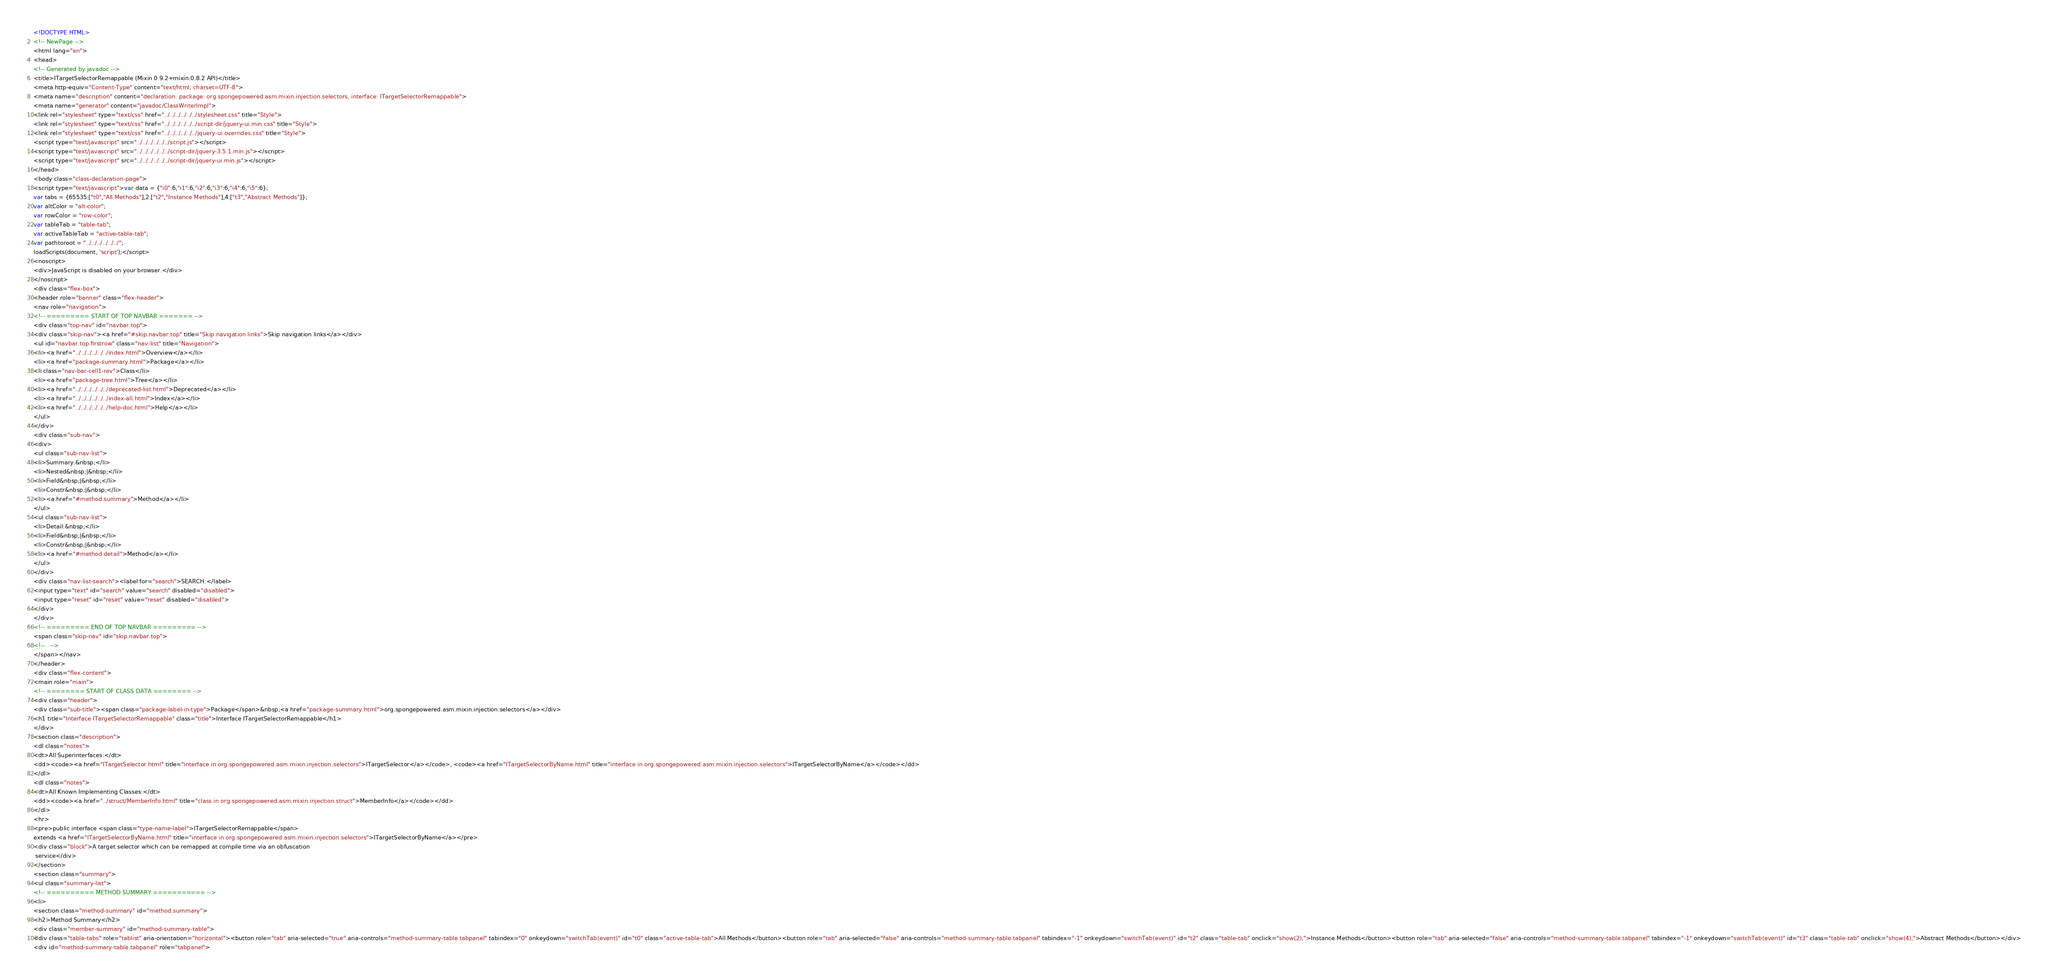Convert code to text. <code><loc_0><loc_0><loc_500><loc_500><_HTML_><!DOCTYPE HTML>
<!-- NewPage -->
<html lang="en">
<head>
<!-- Generated by javadoc -->
<title>ITargetSelectorRemappable (Mixin 0.9.2+mixin.0.8.2 API)</title>
<meta http-equiv="Content-Type" content="text/html; charset=UTF-8">
<meta name="description" content="declaration: package: org.spongepowered.asm.mixin.injection.selectors, interface: ITargetSelectorRemappable">
<meta name="generator" content="javadoc/ClassWriterImpl">
<link rel="stylesheet" type="text/css" href="../../../../../../stylesheet.css" title="Style">
<link rel="stylesheet" type="text/css" href="../../../../../../script-dir/jquery-ui.min.css" title="Style">
<link rel="stylesheet" type="text/css" href="../../../../../../jquery-ui.overrides.css" title="Style">
<script type="text/javascript" src="../../../../../../script.js"></script>
<script type="text/javascript" src="../../../../../../script-dir/jquery-3.5.1.min.js"></script>
<script type="text/javascript" src="../../../../../../script-dir/jquery-ui.min.js"></script>
</head>
<body class="class-declaration-page">
<script type="text/javascript">var data = {"i0":6,"i1":6,"i2":6,"i3":6,"i4":6,"i5":6};
var tabs = {65535:["t0","All Methods"],2:["t2","Instance Methods"],4:["t3","Abstract Methods"]};
var altColor = "alt-color";
var rowColor = "row-color";
var tableTab = "table-tab";
var activeTableTab = "active-table-tab";
var pathtoroot = "../../../../../../";
loadScripts(document, 'script');</script>
<noscript>
<div>JavaScript is disabled on your browser.</div>
</noscript>
<div class="flex-box">
<header role="banner" class="flex-header">
<nav role="navigation">
<!-- ========= START OF TOP NAVBAR ======= -->
<div class="top-nav" id="navbar.top">
<div class="skip-nav"><a href="#skip.navbar.top" title="Skip navigation links">Skip navigation links</a></div>
<ul id="navbar.top.firstrow" class="nav-list" title="Navigation">
<li><a href="../../../../../../index.html">Overview</a></li>
<li><a href="package-summary.html">Package</a></li>
<li class="nav-bar-cell1-rev">Class</li>
<li><a href="package-tree.html">Tree</a></li>
<li><a href="../../../../../../deprecated-list.html">Deprecated</a></li>
<li><a href="../../../../../../index-all.html">Index</a></li>
<li><a href="../../../../../../help-doc.html">Help</a></li>
</ul>
</div>
<div class="sub-nav">
<div>
<ul class="sub-nav-list">
<li>Summary:&nbsp;</li>
<li>Nested&nbsp;|&nbsp;</li>
<li>Field&nbsp;|&nbsp;</li>
<li>Constr&nbsp;|&nbsp;</li>
<li><a href="#method.summary">Method</a></li>
</ul>
<ul class="sub-nav-list">
<li>Detail:&nbsp;</li>
<li>Field&nbsp;|&nbsp;</li>
<li>Constr&nbsp;|&nbsp;</li>
<li><a href="#method.detail">Method</a></li>
</ul>
</div>
<div class="nav-list-search"><label for="search">SEARCH:</label>
<input type="text" id="search" value="search" disabled="disabled">
<input type="reset" id="reset" value="reset" disabled="disabled">
</div>
</div>
<!-- ========= END OF TOP NAVBAR ========= -->
<span class="skip-nav" id="skip.navbar.top">
<!--   -->
</span></nav>
</header>
<div class="flex-content">
<main role="main">
<!-- ======== START OF CLASS DATA ======== -->
<div class="header">
<div class="sub-title"><span class="package-label-in-type">Package</span>&nbsp;<a href="package-summary.html">org.spongepowered.asm.mixin.injection.selectors</a></div>
<h1 title="Interface ITargetSelectorRemappable" class="title">Interface ITargetSelectorRemappable</h1>
</div>
<section class="description">
<dl class="notes">
<dt>All Superinterfaces:</dt>
<dd><code><a href="ITargetSelector.html" title="interface in org.spongepowered.asm.mixin.injection.selectors">ITargetSelector</a></code>, <code><a href="ITargetSelectorByName.html" title="interface in org.spongepowered.asm.mixin.injection.selectors">ITargetSelectorByName</a></code></dd>
</dl>
<dl class="notes">
<dt>All Known Implementing Classes:</dt>
<dd><code><a href="../struct/MemberInfo.html" title="class in org.spongepowered.asm.mixin.injection.struct">MemberInfo</a></code></dd>
</dl>
<hr>
<pre>public interface <span class="type-name-label">ITargetSelectorRemappable</span>
extends <a href="ITargetSelectorByName.html" title="interface in org.spongepowered.asm.mixin.injection.selectors">ITargetSelectorByName</a></pre>
<div class="block">A target selector which can be remapped at compile time via an obfuscation
 service</div>
</section>
<section class="summary">
<ul class="summary-list">
<!-- ========== METHOD SUMMARY =========== -->
<li>
<section class="method-summary" id="method.summary">
<h2>Method Summary</h2>
<div class="member-summary" id="method-summary-table">
<div class="table-tabs" role="tablist" aria-orientation="horizontal"><button role="tab" aria-selected="true" aria-controls="method-summary-table.tabpanel" tabindex="0" onkeydown="switchTab(event)" id="t0" class="active-table-tab">All Methods</button><button role="tab" aria-selected="false" aria-controls="method-summary-table.tabpanel" tabindex="-1" onkeydown="switchTab(event)" id="t2" class="table-tab" onclick="show(2);">Instance Methods</button><button role="tab" aria-selected="false" aria-controls="method-summary-table.tabpanel" tabindex="-1" onkeydown="switchTab(event)" id="t3" class="table-tab" onclick="show(4);">Abstract Methods</button></div>
<div id="method-summary-table.tabpanel" role="tabpanel"></code> 